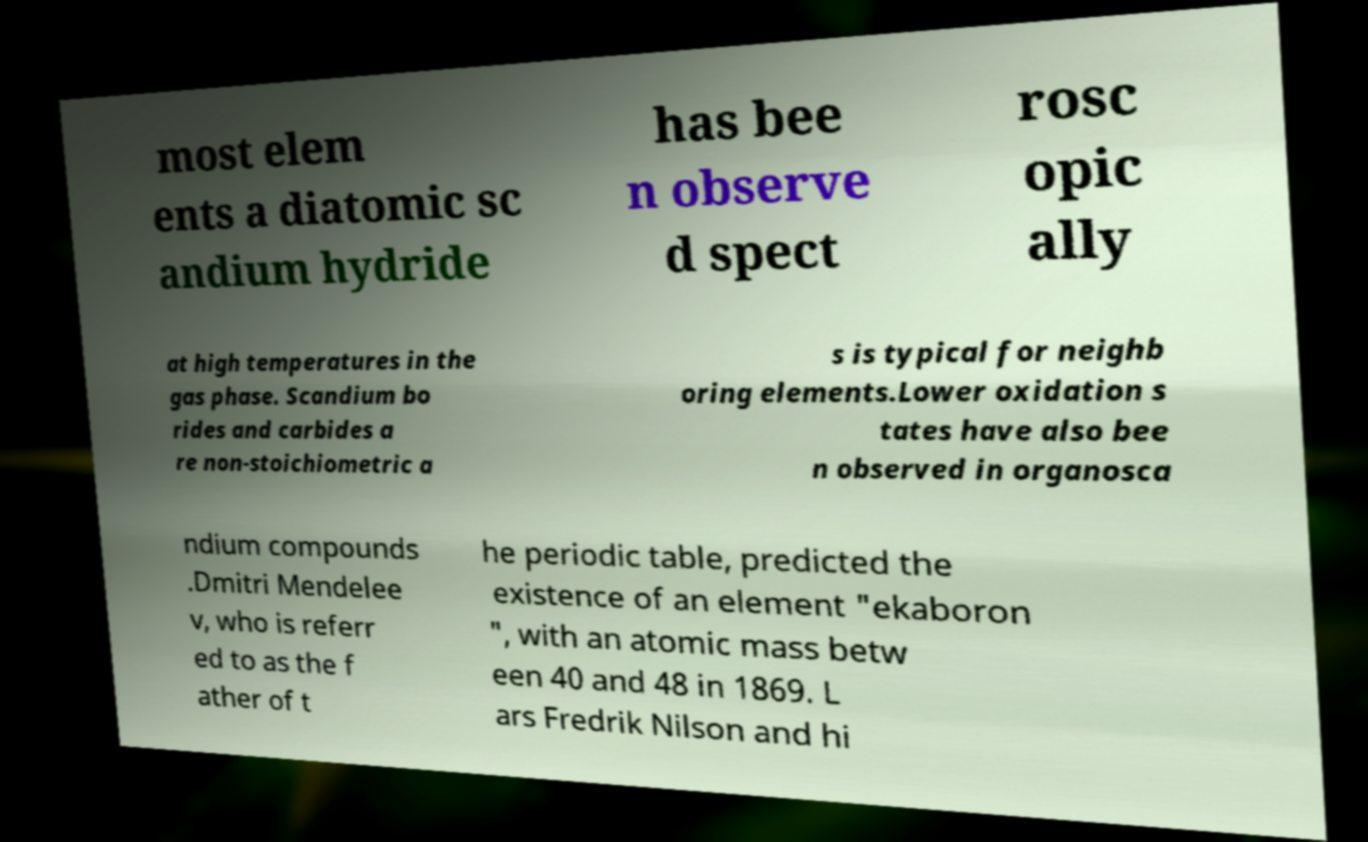Can you accurately transcribe the text from the provided image for me? most elem ents a diatomic sc andium hydride has bee n observe d spect rosc opic ally at high temperatures in the gas phase. Scandium bo rides and carbides a re non-stoichiometric a s is typical for neighb oring elements.Lower oxidation s tates have also bee n observed in organosca ndium compounds .Dmitri Mendelee v, who is referr ed to as the f ather of t he periodic table, predicted the existence of an element "ekaboron ", with an atomic mass betw een 40 and 48 in 1869. L ars Fredrik Nilson and hi 